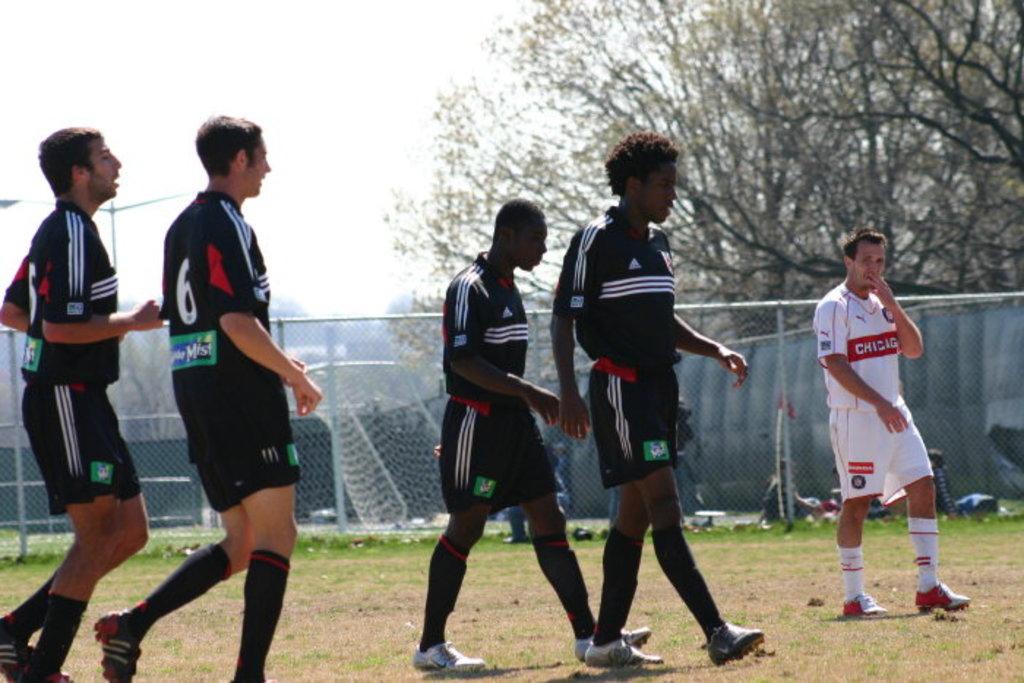What's the color of the numbers behind the dark t-shirts?
Ensure brevity in your answer.  White. What is the team name of the player in white?
Give a very brief answer. Chicago. 